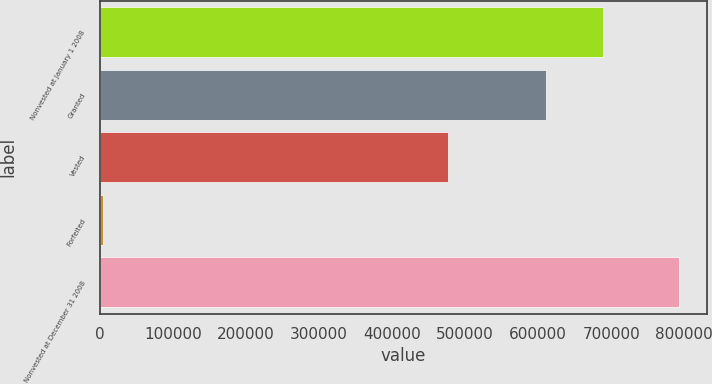Convert chart to OTSL. <chart><loc_0><loc_0><loc_500><loc_500><bar_chart><fcel>Nonvested at January 1 2008<fcel>Granted<fcel>Vested<fcel>Forfeited<fcel>Nonvested at December 31 2008<nl><fcel>688700<fcel>610000<fcel>476000<fcel>5000<fcel>792000<nl></chart> 